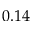<formula> <loc_0><loc_0><loc_500><loc_500>0 . 1 4</formula> 